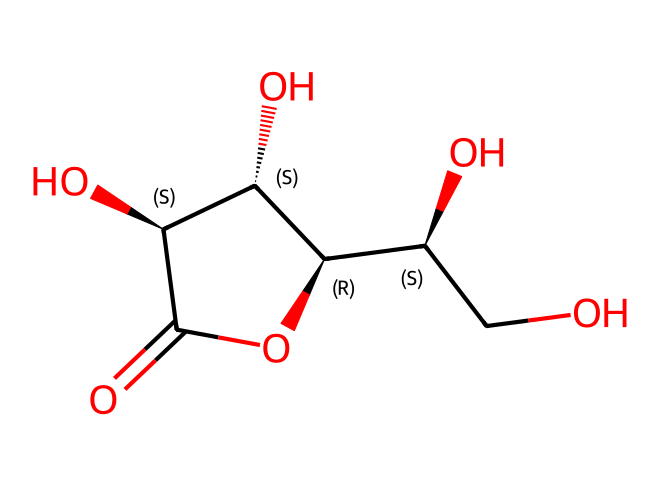What is the molecular formula of vitamin C based on the SMILES representation? To find the molecular formula from the SMILES representation, count the number of each type of atom present. From the representation, there are six carbon atoms (C), eight hydrogen atoms (H), and six oxygen atoms (O). Therefore, the molecular formula can be written as C6H8O6.
Answer: C6H8O6 How many rings are present in the structure of vitamin C? By analyzing the SMILES representation, we observe that the 'C1' and the corresponding 'C' at the end indicates that there is a cyclic structure, meaning there is one ring formed. Therefore, only one ring is present in vitamin C's structure.
Answer: one What type of functional groups are present in vitamin C? From the chemical structure, we can identify several hydroxyl (–OH) groups and a carbonyl (C=O) group. These functional groups are typical for vitamin C, indicating its properties as an alcohol and an acid. Therefore, the key functional groups are hydroxyl and carbonyl.
Answer: hydroxyl and carbonyl How many stereocenters are in the chemical structure of vitamin C? To determine the number of stereocenters, we look for carbon atoms that are bonded to four different substituents. In the provided structure, there are two specific carbon atoms (indicated by '@' in the SMILES) that are connected to different groups, making them chiral centers. Thus, there are two stereocenters present in vitamin C.
Answer: two Is vitamin C a water-soluble or fat-soluble vitamin? Based on the presence of multiple hydroxyl groups in the structure, vitamin C can interact favorably with water, indicating that it is polar. This characteristic confirms that vitamin C is a water-soluble vitamin.
Answer: water-soluble What is the basic function of vitamin C in the human body? Vitamin C is primarily known for its role in collagen synthesis, which is crucial for maintaining connective tissue and skin health. It also functions as an antioxidant, helping to protect cells from damage. Therefore, the basic function encompasses supporting skin and tissue health as well as acting as an antioxidant.
Answer: collagen synthesis and antioxidant 